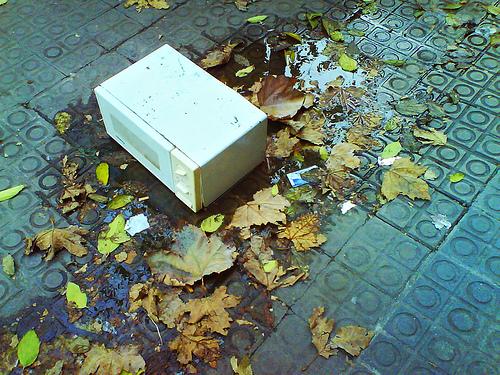What color is the box?
Keep it brief. White. What is on the ground other than leaves?
Give a very brief answer. Microwave. Is the microwave attached to an outlet?
Concise answer only. No. 